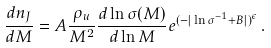<formula> <loc_0><loc_0><loc_500><loc_500>\frac { d n _ { J } } { d M } = A \frac { \rho _ { u } } { M ^ { 2 } } \frac { d \ln { \sigma ( M ) } } { d \ln { M } } e ^ { ( - | \ln \sigma ^ { - 1 } + B | ) ^ { \epsilon } } \, .</formula> 